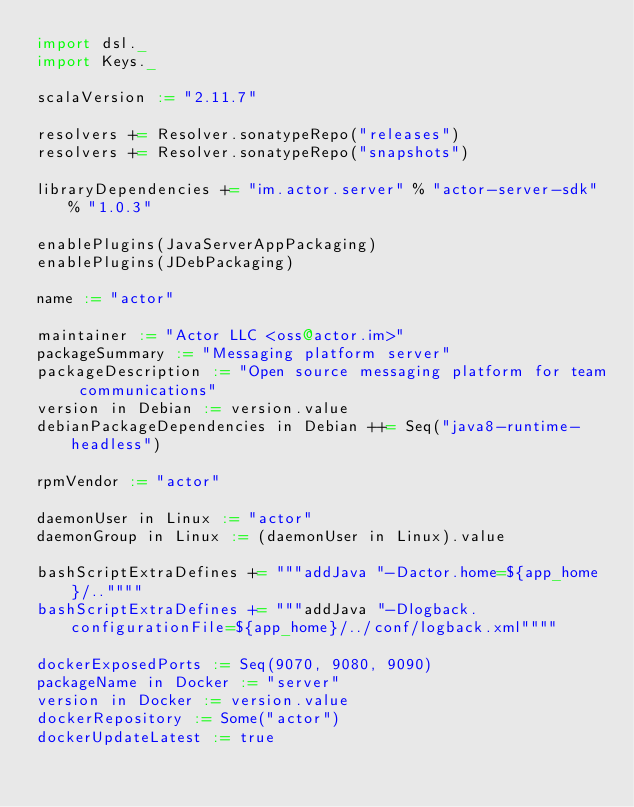<code> <loc_0><loc_0><loc_500><loc_500><_Scala_>import dsl._
import Keys._

scalaVersion := "2.11.7"

resolvers += Resolver.sonatypeRepo("releases")
resolvers += Resolver.sonatypeRepo("snapshots")

libraryDependencies += "im.actor.server" % "actor-server-sdk" % "1.0.3"

enablePlugins(JavaServerAppPackaging)
enablePlugins(JDebPackaging)

name := "actor"

maintainer := "Actor LLC <oss@actor.im>"
packageSummary := "Messaging platform server"
packageDescription := "Open source messaging platform for team communications"
version in Debian := version.value
debianPackageDependencies in Debian ++= Seq("java8-runtime-headless")

rpmVendor := "actor"

daemonUser in Linux := "actor"
daemonGroup in Linux := (daemonUser in Linux).value

bashScriptExtraDefines += """addJava "-Dactor.home=${app_home}/..""""
bashScriptExtraDefines += """addJava "-Dlogback.configurationFile=${app_home}/../conf/logback.xml""""

dockerExposedPorts := Seq(9070, 9080, 9090)
packageName in Docker := "server"
version in Docker := version.value
dockerRepository := Some("actor")
dockerUpdateLatest := true
</code> 